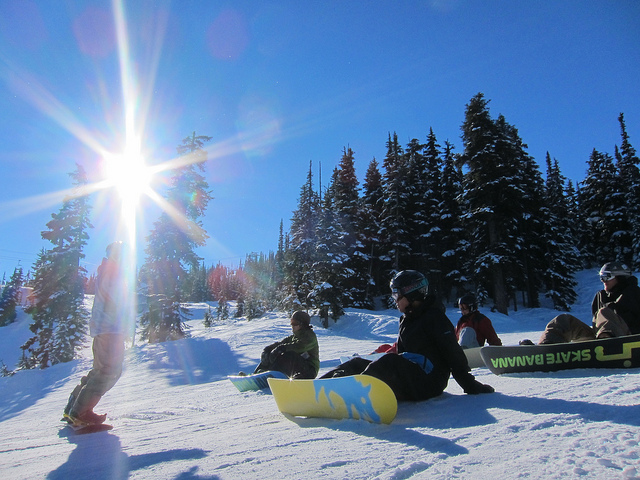Read and extract the text from this image. SKATE BANANA 